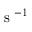Convert formula to latex. <formula><loc_0><loc_0><loc_500><loc_500>s ^ { - 1 }</formula> 